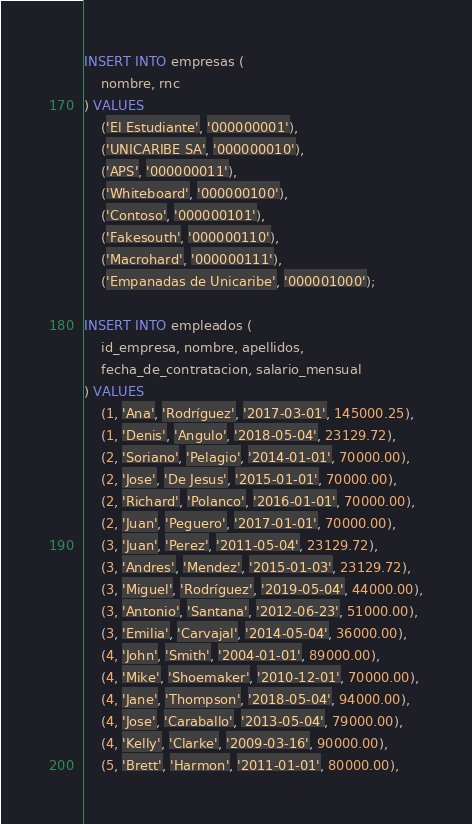<code> <loc_0><loc_0><loc_500><loc_500><_SQL_>INSERT INTO empresas (
    nombre, rnc
) VALUES 
    ('El Estudiante', '000000001'),
    ('UNICARIBE SA', '000000010'),
    ('APS', '000000011'),
    ('Whiteboard', '000000100'),
    ('Contoso', '000000101'),
    ('Fakesouth', '000000110'),
    ('Macrohard', '000000111'),
    ('Empanadas de Unicaribe', '000001000');

INSERT INTO empleados (
    id_empresa, nombre, apellidos,
    fecha_de_contratacion, salario_mensual
) VALUES
    (1, 'Ana', 'Rodríguez', '2017-03-01', 145000.25),
    (1, 'Denis', 'Angulo', '2018-05-04', 23129.72),
    (2, 'Soriano', 'Pelagio', '2014-01-01', 70000.00),
    (2, 'Jose', 'De Jesus', '2015-01-01', 70000.00),
    (2, 'Richard', 'Polanco', '2016-01-01', 70000.00),
    (2, 'Juan', 'Peguero', '2017-01-01', 70000.00),
    (3, 'Juan', 'Perez', '2011-05-04', 23129.72),
    (3, 'Andres', 'Mendez', '2015-01-03', 23129.72),
    (3, 'Miguel', 'Rodríguez', '2019-05-04', 44000.00),
    (3, 'Antonio', 'Santana', '2012-06-23', 51000.00),
    (3, 'Emilia', 'Carvajal', '2014-05-04', 36000.00),
    (4, 'John', 'Smith', '2004-01-01', 89000.00),
    (4, 'Mike', 'Shoemaker', '2010-12-01', 70000.00),
    (4, 'Jane', 'Thompson', '2018-05-04', 94000.00),
    (4, 'Jose', 'Caraballo', '2013-05-04', 79000.00),
    (4, 'Kelly', 'Clarke', '2009-03-16', 90000.00),
    (5, 'Brett', 'Harmon', '2011-01-01', 80000.00),</code> 